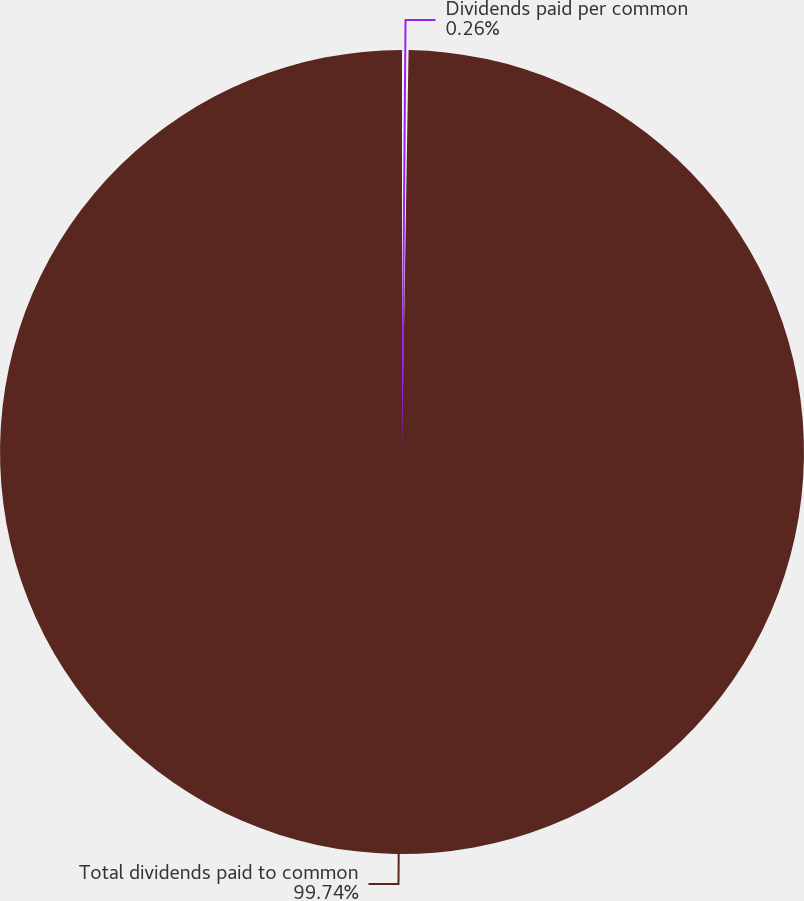<chart> <loc_0><loc_0><loc_500><loc_500><pie_chart><fcel>Dividends paid per common<fcel>Total dividends paid to common<nl><fcel>0.26%<fcel>99.74%<nl></chart> 